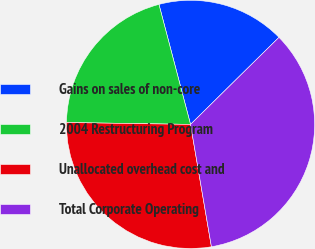<chart> <loc_0><loc_0><loc_500><loc_500><pie_chart><fcel>Gains on sales of non-core<fcel>2004 Restructuring Program<fcel>Unallocated overhead cost and<fcel>Total Corporate Operating<nl><fcel>16.72%<fcel>20.66%<fcel>27.93%<fcel>34.68%<nl></chart> 